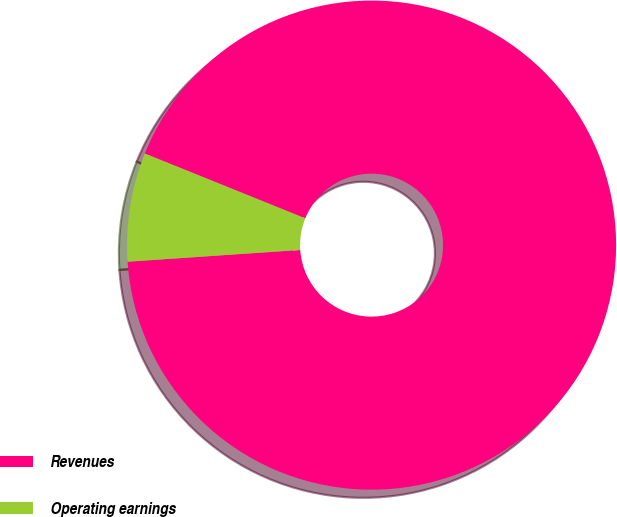Convert chart. <chart><loc_0><loc_0><loc_500><loc_500><pie_chart><fcel>Revenues<fcel>Operating earnings<nl><fcel>92.81%<fcel>7.19%<nl></chart> 